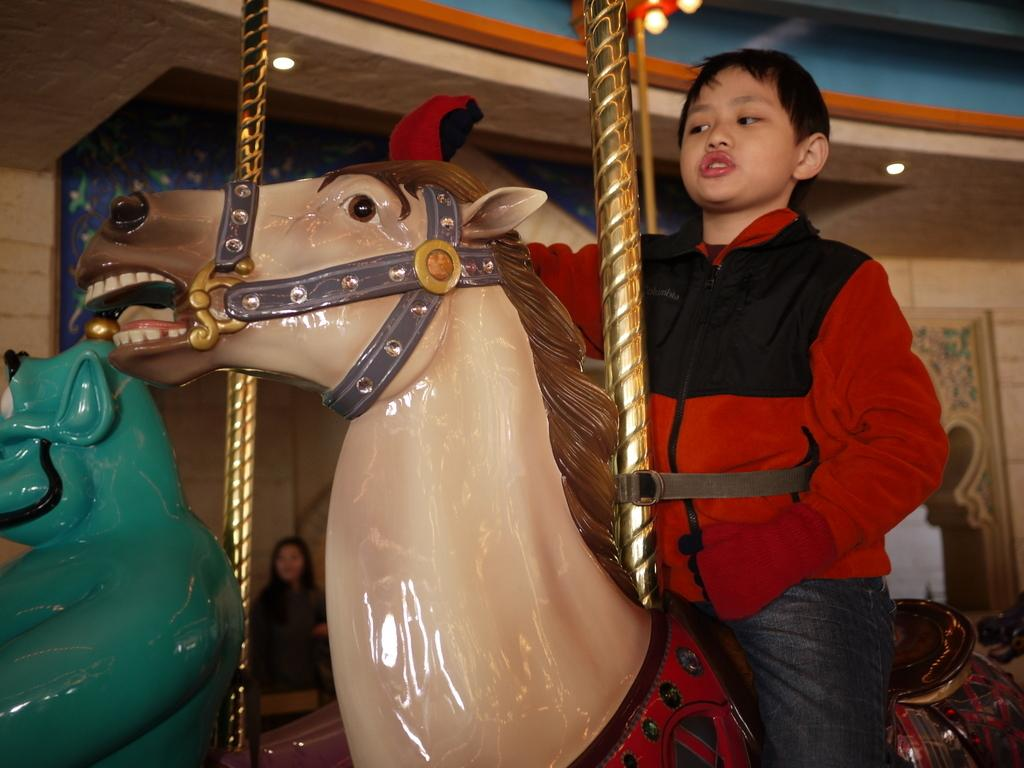What is the main subject of the image? The main subject of the image is a kid. What is the kid doing in the image? The kid is riding a carousel ride. Can you describe the person behind the kid? There is a person behind the kid, but their specific features or actions are not mentioned in the facts. What can be seen in the background of the image? A: There is a wall in the background of the image. What type of lighting is present in the image? Ceiling lights are visible at the top of the image. What type of plane is the kid flying in the image? There is no plane present in the image; the kid is riding a carousel ride. What kind of error is the kid making in the image? There is no mention of an error in the image; the kid is simply riding a carousel ride. 